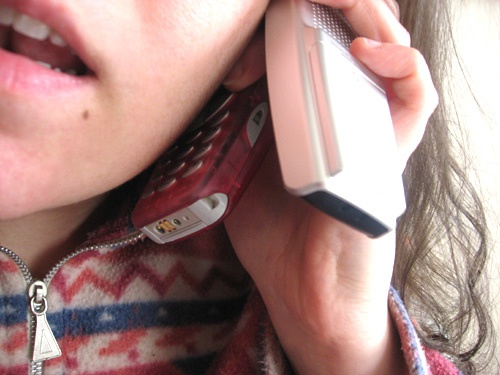Describe the objects in this image and their specific colors. I can see people in brown, lightpink, white, and black tones, cell phone in brown, white, lightpink, and pink tones, and cell phone in brown, black, maroon, and gray tones in this image. 